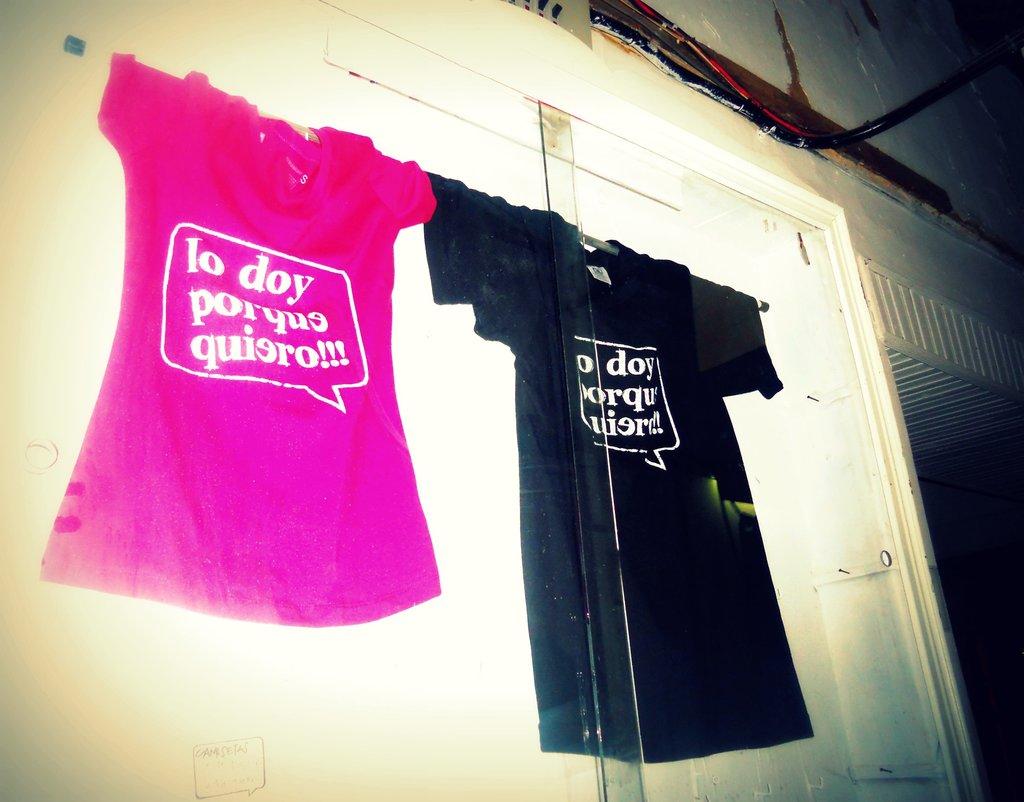What size is depicted on the label of the pink shirt?
Your response must be concise. Small. What is the first word on the pink shirt?
Provide a succinct answer. Lo. 